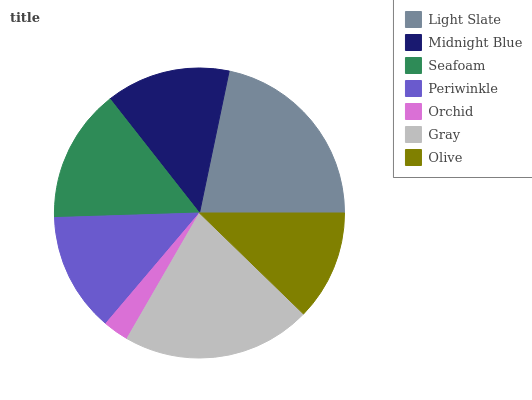Is Orchid the minimum?
Answer yes or no. Yes. Is Light Slate the maximum?
Answer yes or no. Yes. Is Midnight Blue the minimum?
Answer yes or no. No. Is Midnight Blue the maximum?
Answer yes or no. No. Is Light Slate greater than Midnight Blue?
Answer yes or no. Yes. Is Midnight Blue less than Light Slate?
Answer yes or no. Yes. Is Midnight Blue greater than Light Slate?
Answer yes or no. No. Is Light Slate less than Midnight Blue?
Answer yes or no. No. Is Midnight Blue the high median?
Answer yes or no. Yes. Is Midnight Blue the low median?
Answer yes or no. Yes. Is Orchid the high median?
Answer yes or no. No. Is Olive the low median?
Answer yes or no. No. 